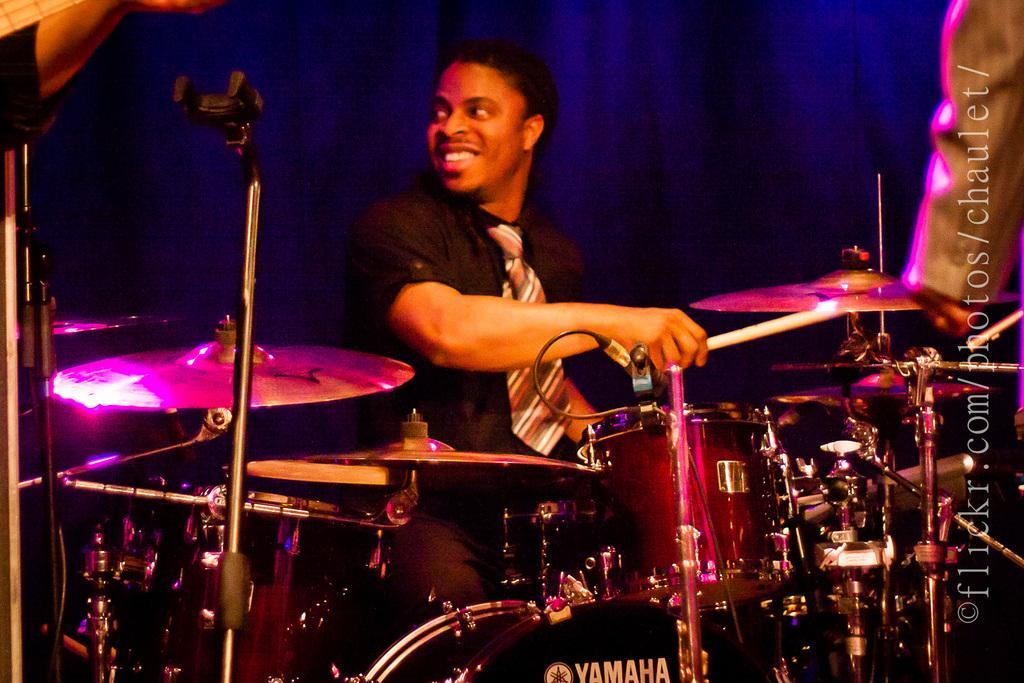Could you give a brief overview of what you see in this image? It is a picture of a man playing drums. In the center of the image there is a man wearing a black a shirt and a checkered tie holding sticks and playing drums, he is smiling. In the background there is a blue colored curtain. In the foreground on the drums Yamaha is written on it 